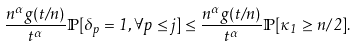Convert formula to latex. <formula><loc_0><loc_0><loc_500><loc_500>\frac { n ^ { \alpha } g ( t / n ) } { t ^ { \alpha } } { \mathbb { P } } [ \delta _ { p } = 1 , \forall p \leq j ] \leq \frac { n ^ { \alpha } g ( t / n ) } { t ^ { \alpha } } { \mathbb { P } } [ \kappa _ { 1 } \geq n / 2 ] .</formula> 